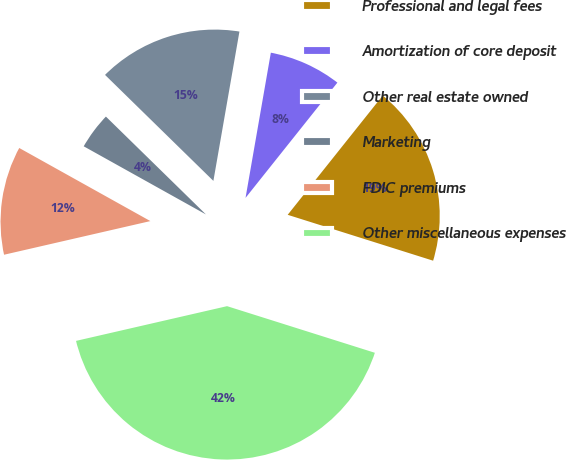Convert chart to OTSL. <chart><loc_0><loc_0><loc_500><loc_500><pie_chart><fcel>Professional and legal fees<fcel>Amortization of core deposit<fcel>Other real estate owned<fcel>Marketing<fcel>FDIC premiums<fcel>Other miscellaneous expenses<nl><fcel>19.15%<fcel>7.96%<fcel>15.42%<fcel>4.23%<fcel>11.69%<fcel>41.53%<nl></chart> 